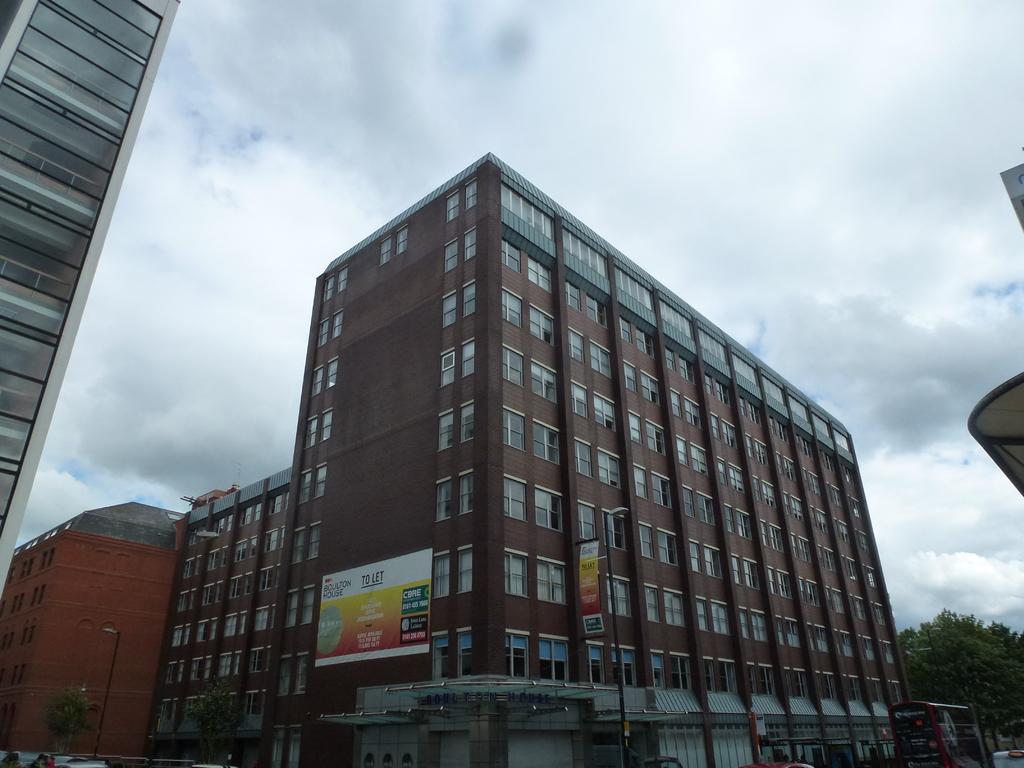Describe this image in one or two sentences. In this image we can see buildings, trees, light poles, hoardings, vehicles and cloudy sky. 